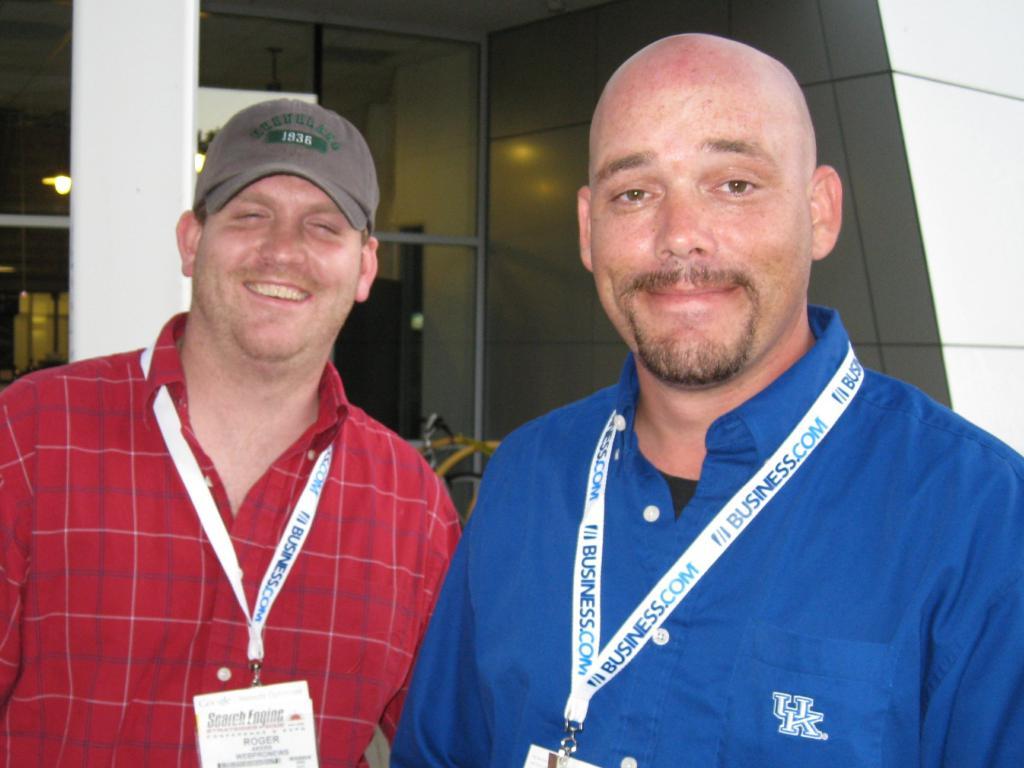What letters are on the pocket of the blue shirt?
Provide a succinct answer. Uk. 